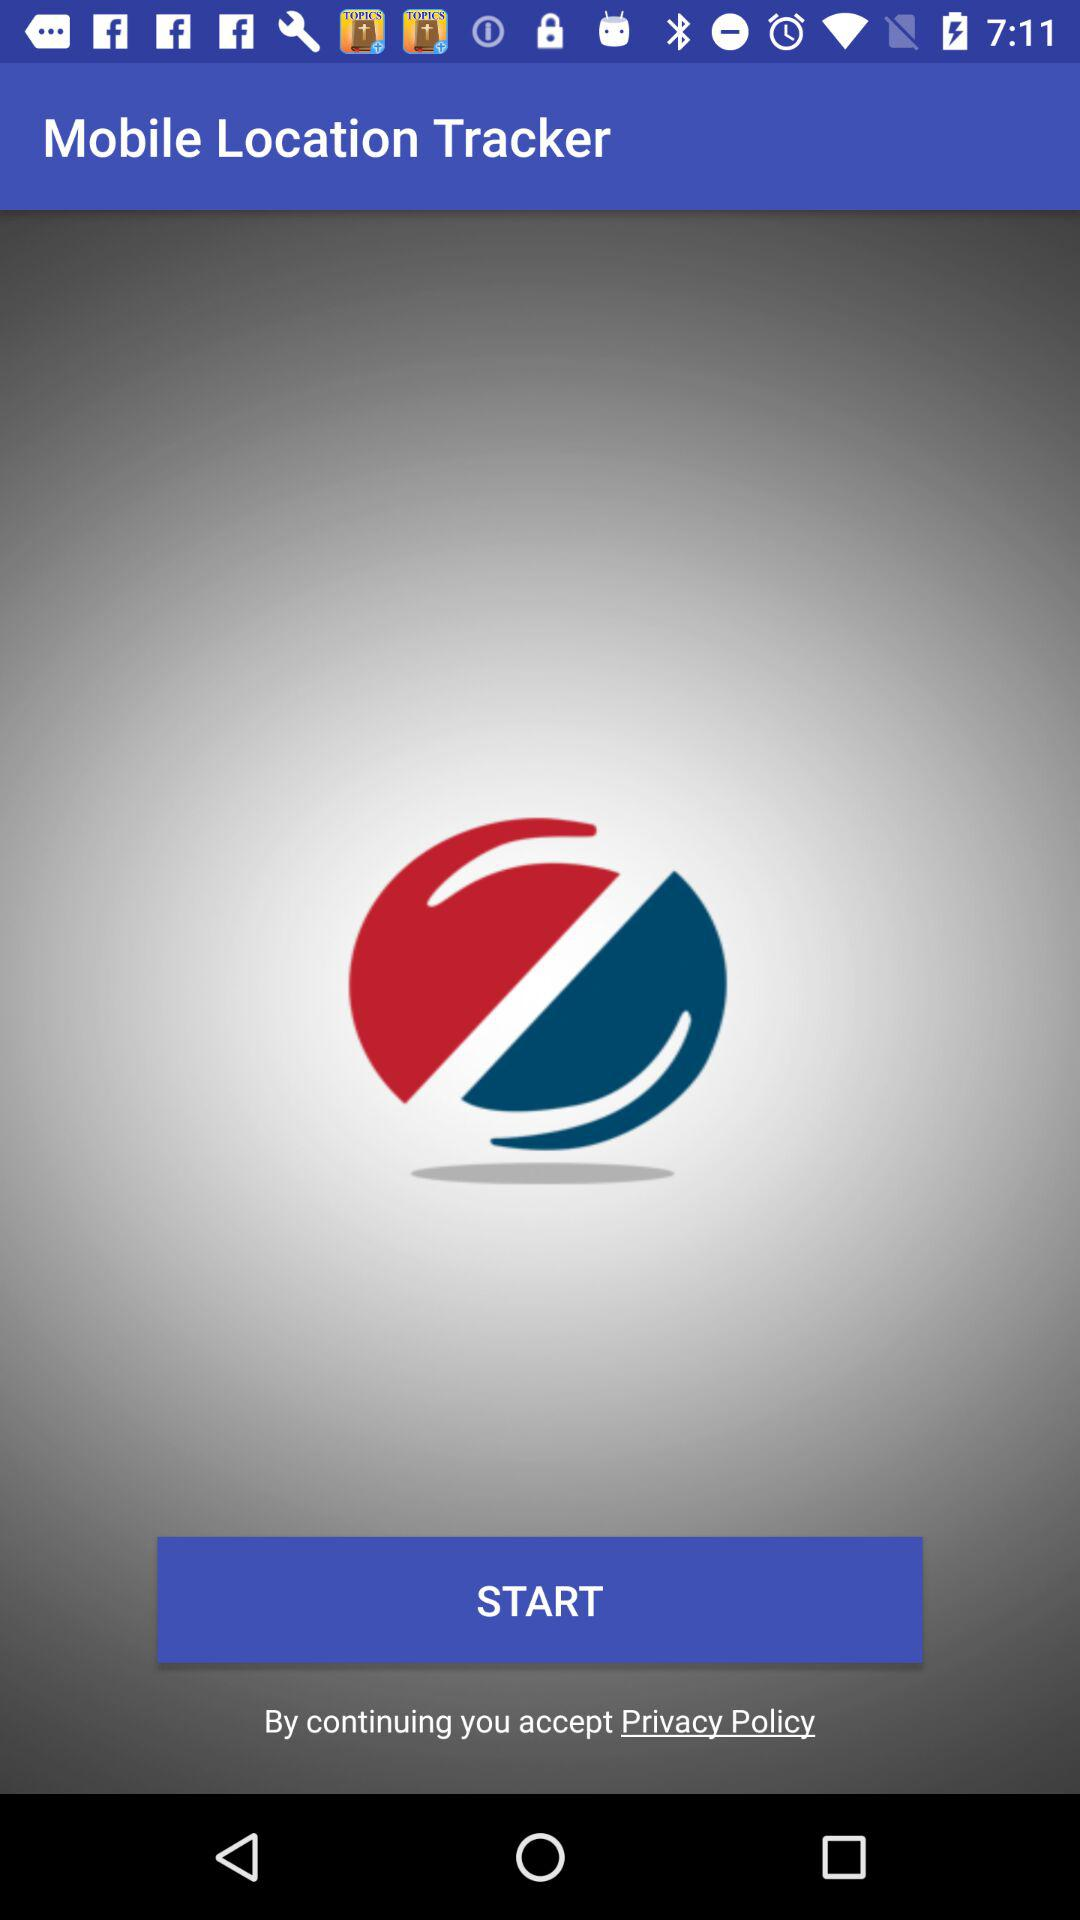What is the application name? The application name is "Mobile Location Tracker". 